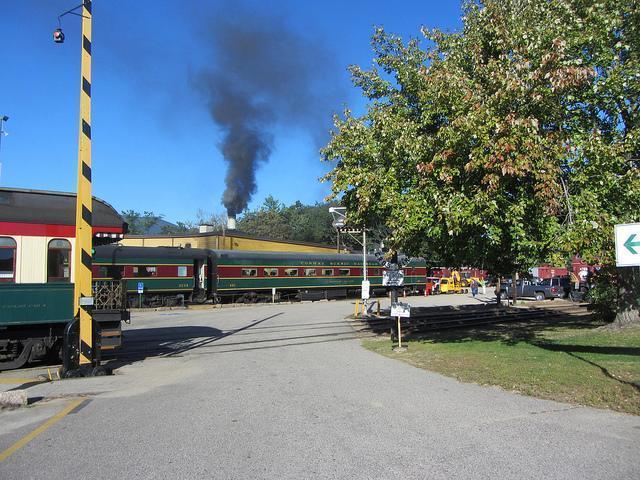How many trains are in the photo?
Give a very brief answer. 2. 